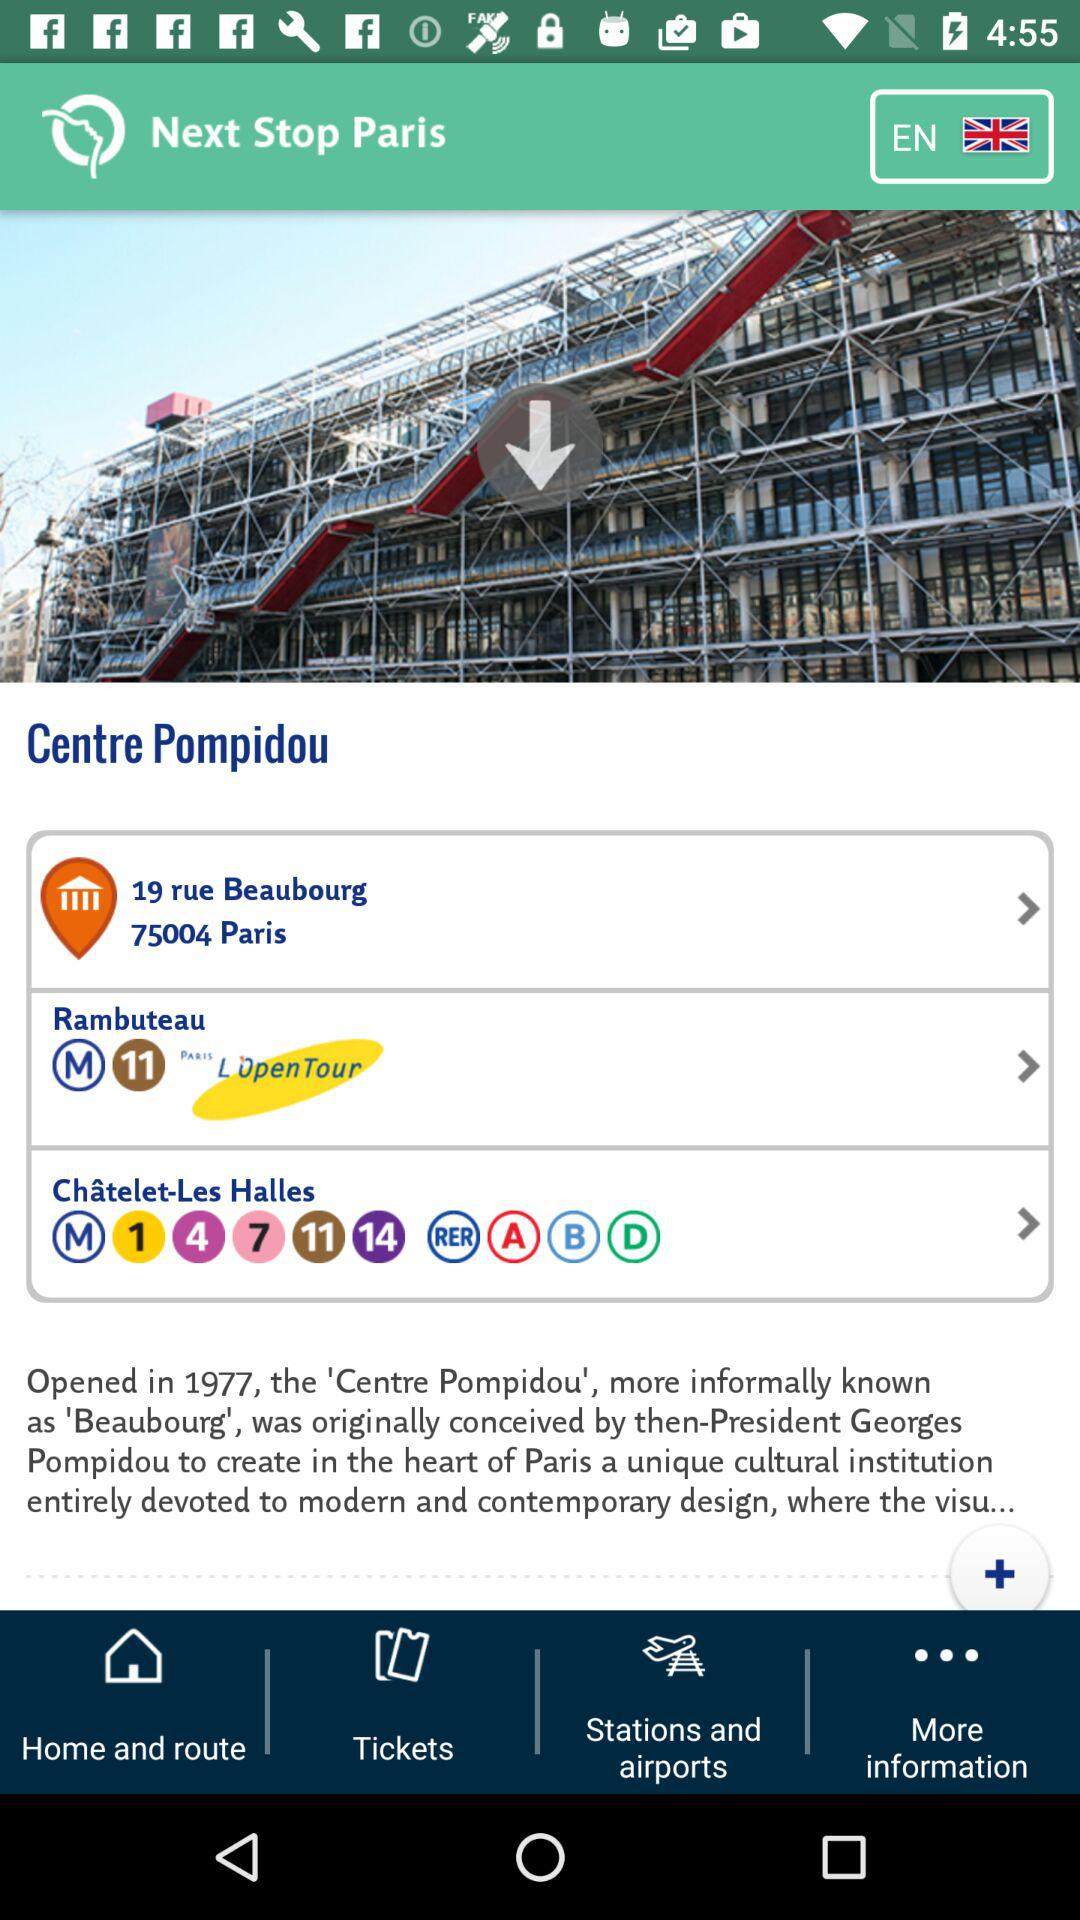What country is selected? The selected country is England. 